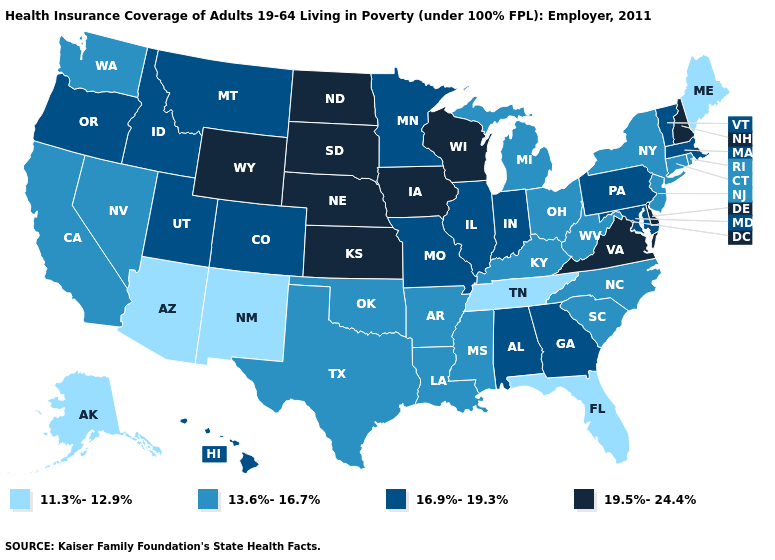Which states have the lowest value in the USA?
Keep it brief. Alaska, Arizona, Florida, Maine, New Mexico, Tennessee. What is the value of Maine?
Give a very brief answer. 11.3%-12.9%. Name the states that have a value in the range 13.6%-16.7%?
Short answer required. Arkansas, California, Connecticut, Kentucky, Louisiana, Michigan, Mississippi, Nevada, New Jersey, New York, North Carolina, Ohio, Oklahoma, Rhode Island, South Carolina, Texas, Washington, West Virginia. What is the highest value in the USA?
Quick response, please. 19.5%-24.4%. Among the states that border North Dakota , does South Dakota have the highest value?
Write a very short answer. Yes. What is the value of Wyoming?
Keep it brief. 19.5%-24.4%. What is the highest value in the USA?
Concise answer only. 19.5%-24.4%. What is the value of Massachusetts?
Quick response, please. 16.9%-19.3%. What is the value of West Virginia?
Be succinct. 13.6%-16.7%. What is the value of Utah?
Answer briefly. 16.9%-19.3%. Does Minnesota have the highest value in the MidWest?
Quick response, please. No. What is the value of Utah?
Quick response, please. 16.9%-19.3%. What is the value of Arkansas?
Quick response, please. 13.6%-16.7%. What is the lowest value in the Northeast?
Write a very short answer. 11.3%-12.9%. Does New Mexico have the highest value in the West?
Short answer required. No. 